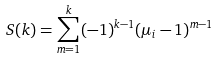<formula> <loc_0><loc_0><loc_500><loc_500>S ( k ) = \sum _ { m = 1 } ^ { k } ( - 1 ) ^ { k - 1 } ( \mu _ { i } - 1 ) ^ { m - 1 }</formula> 